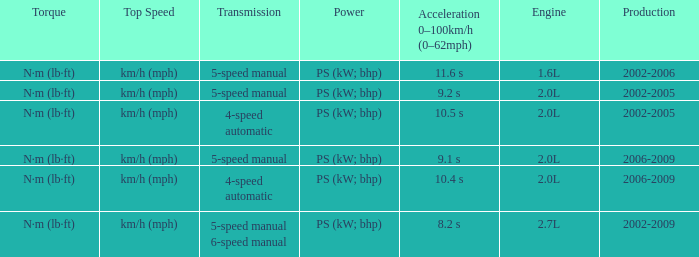What is the top speed of a 4-speed automatic with production in 2002-2005? Km/h (mph). 